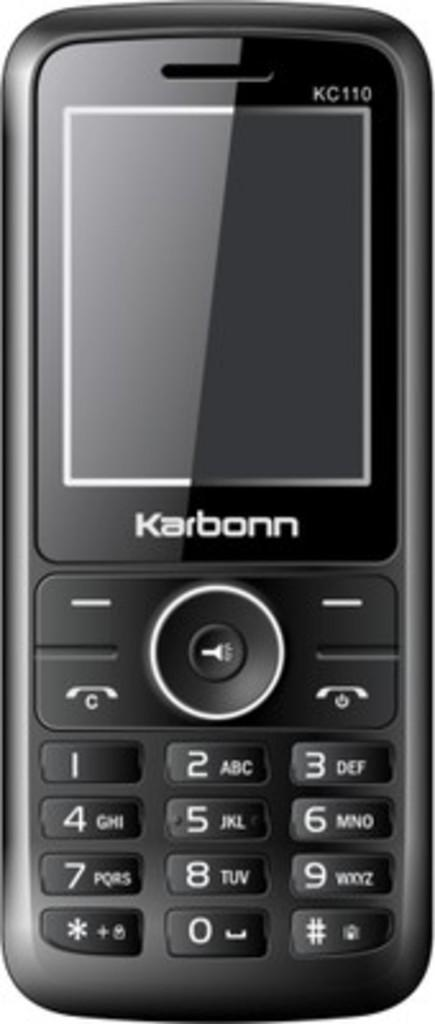<image>
Provide a brief description of the given image. A black cell phone says Karbonn under the screen. 